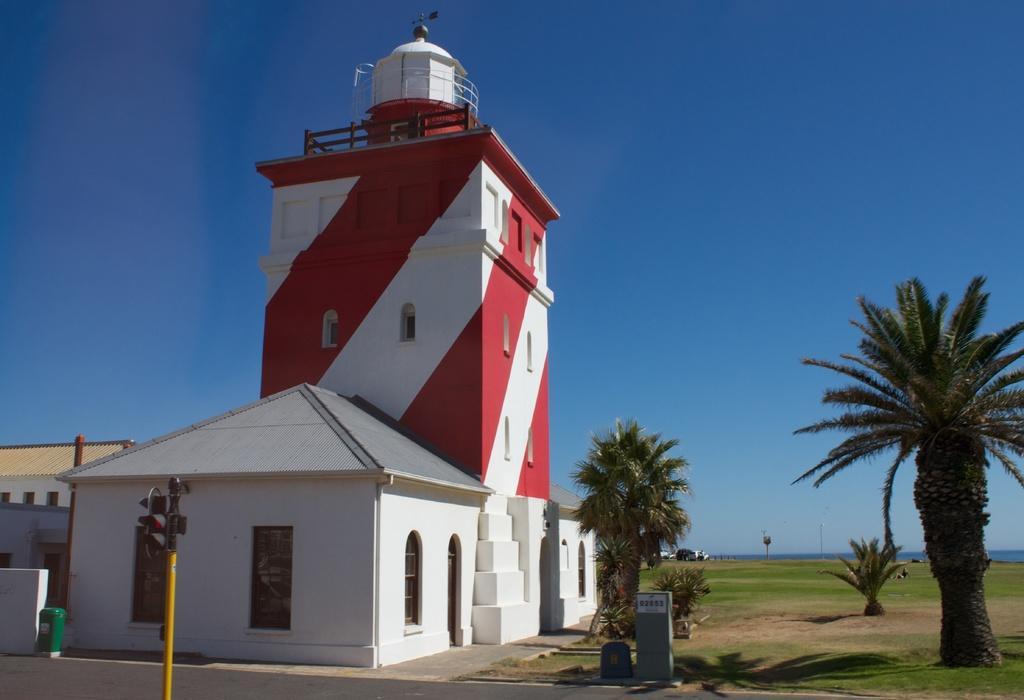Can you describe this image briefly? In the center of the image there is a building. There is a traffic signal. There are trees. There is grass. At the top of the image there is sky. 